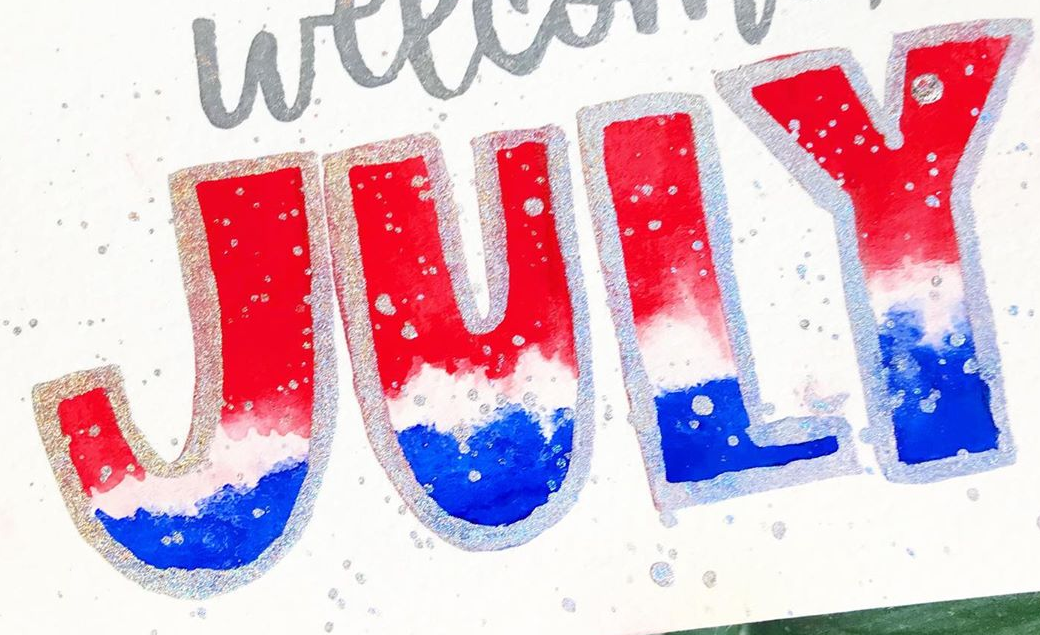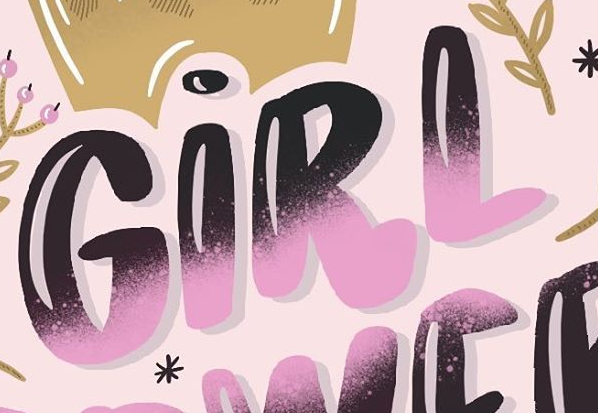What text is displayed in these images sequentially, separated by a semicolon? JULY; GIRL 